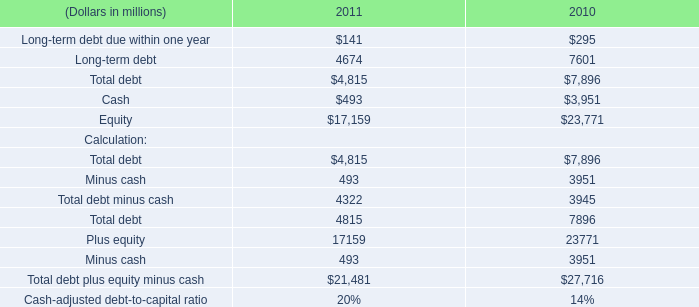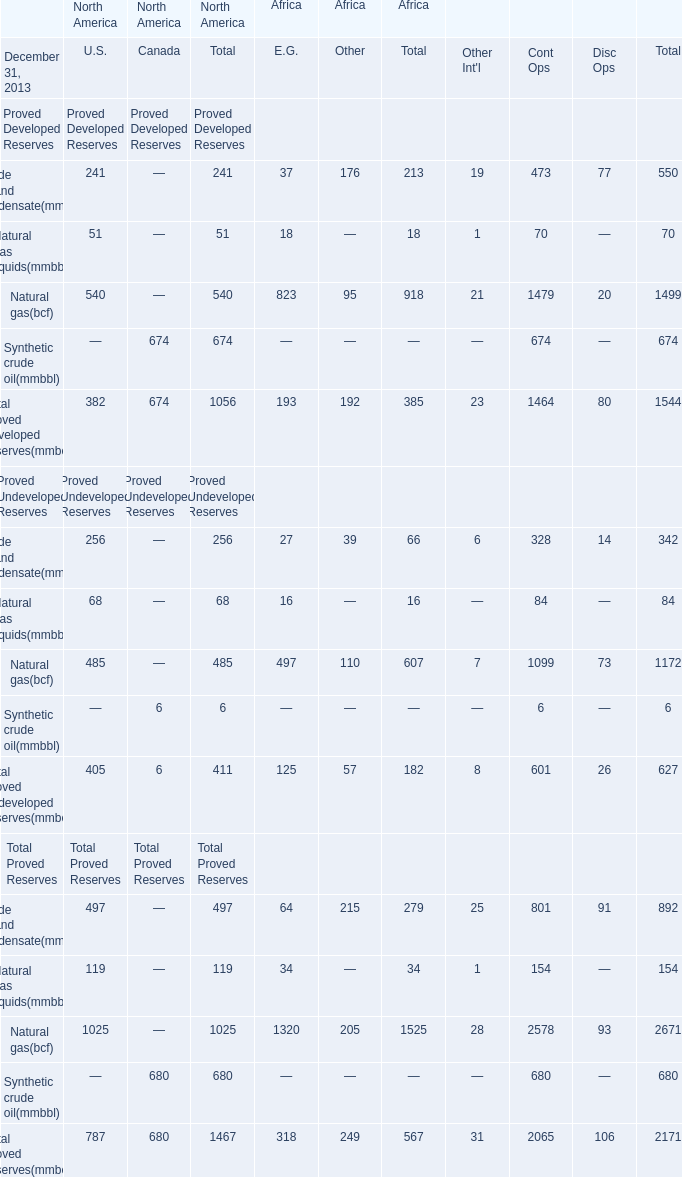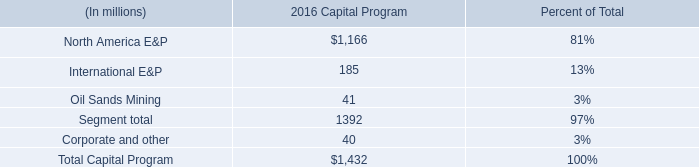In the section with lowest amount of Total proved developed reserves(mmboe), what's the increasing rate of Natural gas(bcf)? 
Computations: ((23 - 7) / 7)
Answer: 2.28571. 